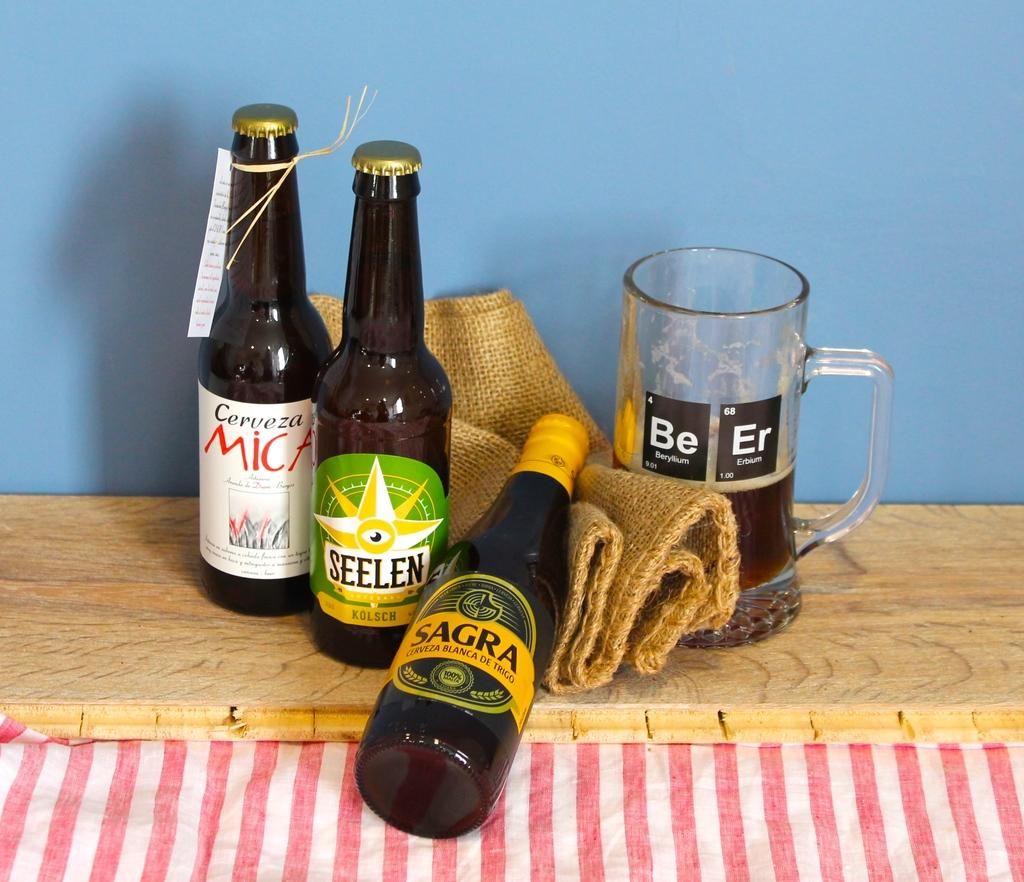<image>
Provide a brief description of the given image. A bottle of sagra lies on a brown cloth 